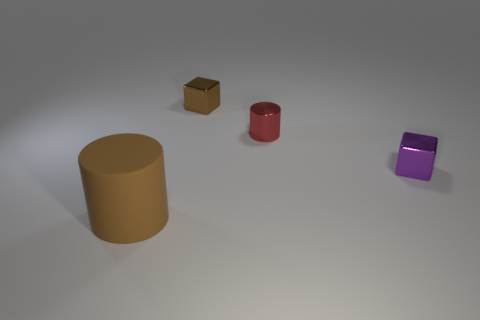How do the sizes of the objects compare to each other? In the image, we can see various objects differing in size. The brown matte cylinder is the largest, followed by the red cylinder, which is smaller in height. The gold cube and purple cube are significantly smaller than the cylinders, with the gold cube being the smallest of all the objects. 